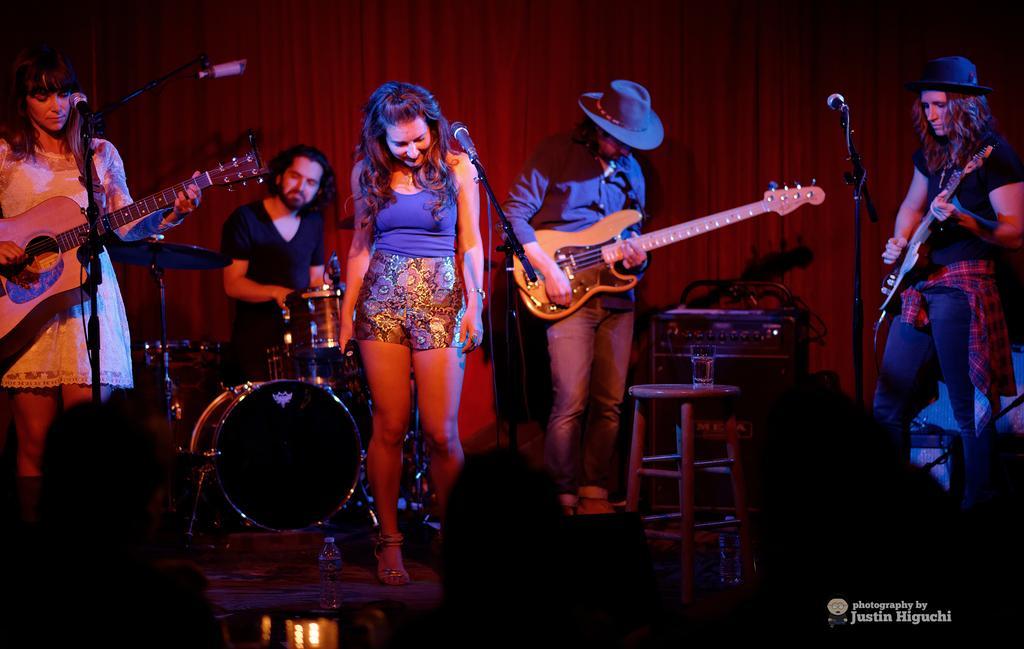Could you give a brief overview of what you see in this image? In this image i can see five people on the face. on the right side i can see a girl wearing a red color scarf and holding a guitar and she is wearing blue color cap on her head. on the middle there is a table ,near to table a man stand wearing a blue color cap and holding a guitar on his hand beside him a girl wearing a blue color jacket in front of her there is a mike. back side of her a man sit on the chair and playing a musical instrument. On the left side corner a woman stand ,holding a guitar and near to the mike 